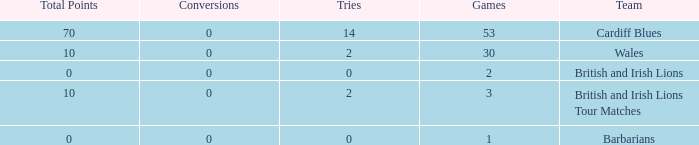What is the average number of tries for British and Irish Lions with less than 2 games? None. 